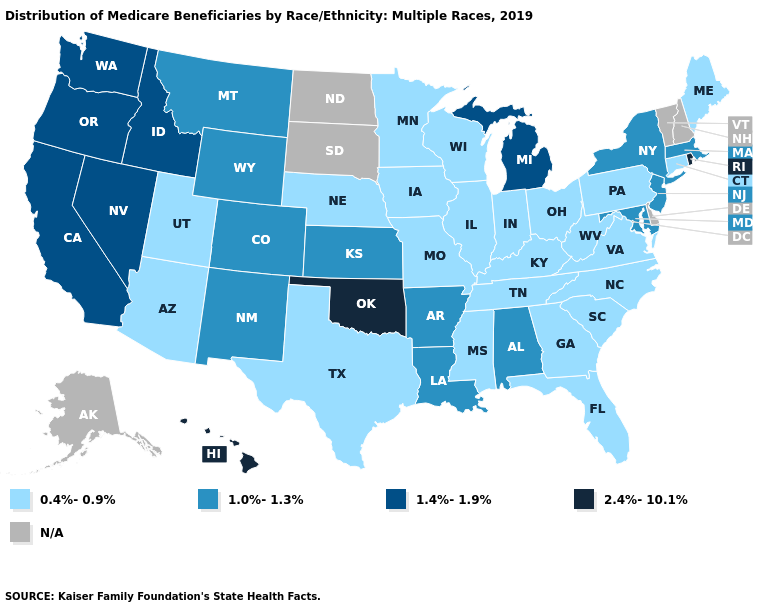Among the states that border Michigan , which have the lowest value?
Be succinct. Indiana, Ohio, Wisconsin. Does Michigan have the lowest value in the USA?
Short answer required. No. What is the highest value in the USA?
Short answer required. 2.4%-10.1%. Name the states that have a value in the range 0.4%-0.9%?
Give a very brief answer. Arizona, Connecticut, Florida, Georgia, Illinois, Indiana, Iowa, Kentucky, Maine, Minnesota, Mississippi, Missouri, Nebraska, North Carolina, Ohio, Pennsylvania, South Carolina, Tennessee, Texas, Utah, Virginia, West Virginia, Wisconsin. Which states have the lowest value in the USA?
Keep it brief. Arizona, Connecticut, Florida, Georgia, Illinois, Indiana, Iowa, Kentucky, Maine, Minnesota, Mississippi, Missouri, Nebraska, North Carolina, Ohio, Pennsylvania, South Carolina, Tennessee, Texas, Utah, Virginia, West Virginia, Wisconsin. Name the states that have a value in the range N/A?
Be succinct. Alaska, Delaware, New Hampshire, North Dakota, South Dakota, Vermont. Which states hav the highest value in the West?
Give a very brief answer. Hawaii. Name the states that have a value in the range 1.0%-1.3%?
Be succinct. Alabama, Arkansas, Colorado, Kansas, Louisiana, Maryland, Massachusetts, Montana, New Jersey, New Mexico, New York, Wyoming. Name the states that have a value in the range 0.4%-0.9%?
Quick response, please. Arizona, Connecticut, Florida, Georgia, Illinois, Indiana, Iowa, Kentucky, Maine, Minnesota, Mississippi, Missouri, Nebraska, North Carolina, Ohio, Pennsylvania, South Carolina, Tennessee, Texas, Utah, Virginia, West Virginia, Wisconsin. What is the value of North Carolina?
Give a very brief answer. 0.4%-0.9%. Does Florida have the highest value in the USA?
Short answer required. No. What is the value of Nevada?
Concise answer only. 1.4%-1.9%. What is the value of Montana?
Short answer required. 1.0%-1.3%. Does the map have missing data?
Keep it brief. Yes. Does the first symbol in the legend represent the smallest category?
Concise answer only. Yes. 